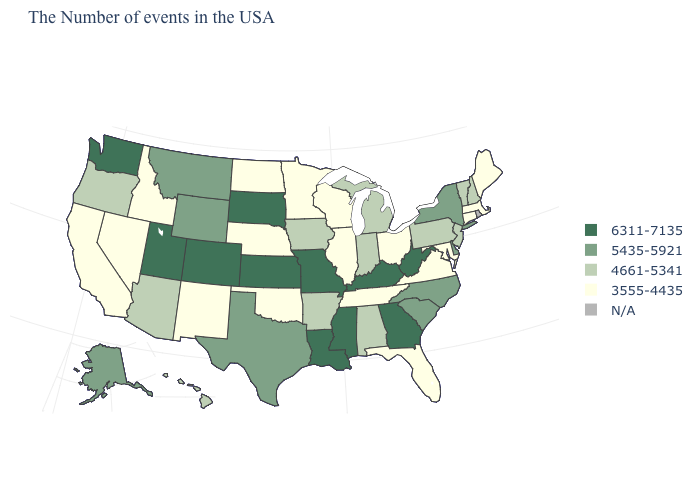What is the lowest value in the USA?
Write a very short answer. 3555-4435. How many symbols are there in the legend?
Concise answer only. 5. What is the value of New Hampshire?
Answer briefly. 4661-5341. Name the states that have a value in the range 6311-7135?
Quick response, please. West Virginia, Georgia, Kentucky, Mississippi, Louisiana, Missouri, Kansas, South Dakota, Colorado, Utah, Washington. Name the states that have a value in the range 3555-4435?
Give a very brief answer. Maine, Massachusetts, Connecticut, Maryland, Virginia, Ohio, Florida, Tennessee, Wisconsin, Illinois, Minnesota, Nebraska, Oklahoma, North Dakota, New Mexico, Idaho, Nevada, California. Does South Dakota have the highest value in the MidWest?
Short answer required. Yes. Name the states that have a value in the range 5435-5921?
Concise answer only. New York, Delaware, North Carolina, South Carolina, Texas, Wyoming, Montana, Alaska. Among the states that border North Dakota , does Montana have the lowest value?
Give a very brief answer. No. How many symbols are there in the legend?
Short answer required. 5. What is the highest value in states that border Louisiana?
Concise answer only. 6311-7135. Does Indiana have the highest value in the USA?
Be succinct. No. Which states have the highest value in the USA?
Give a very brief answer. West Virginia, Georgia, Kentucky, Mississippi, Louisiana, Missouri, Kansas, South Dakota, Colorado, Utah, Washington. Does the first symbol in the legend represent the smallest category?
Quick response, please. No. What is the lowest value in the USA?
Concise answer only. 3555-4435. 